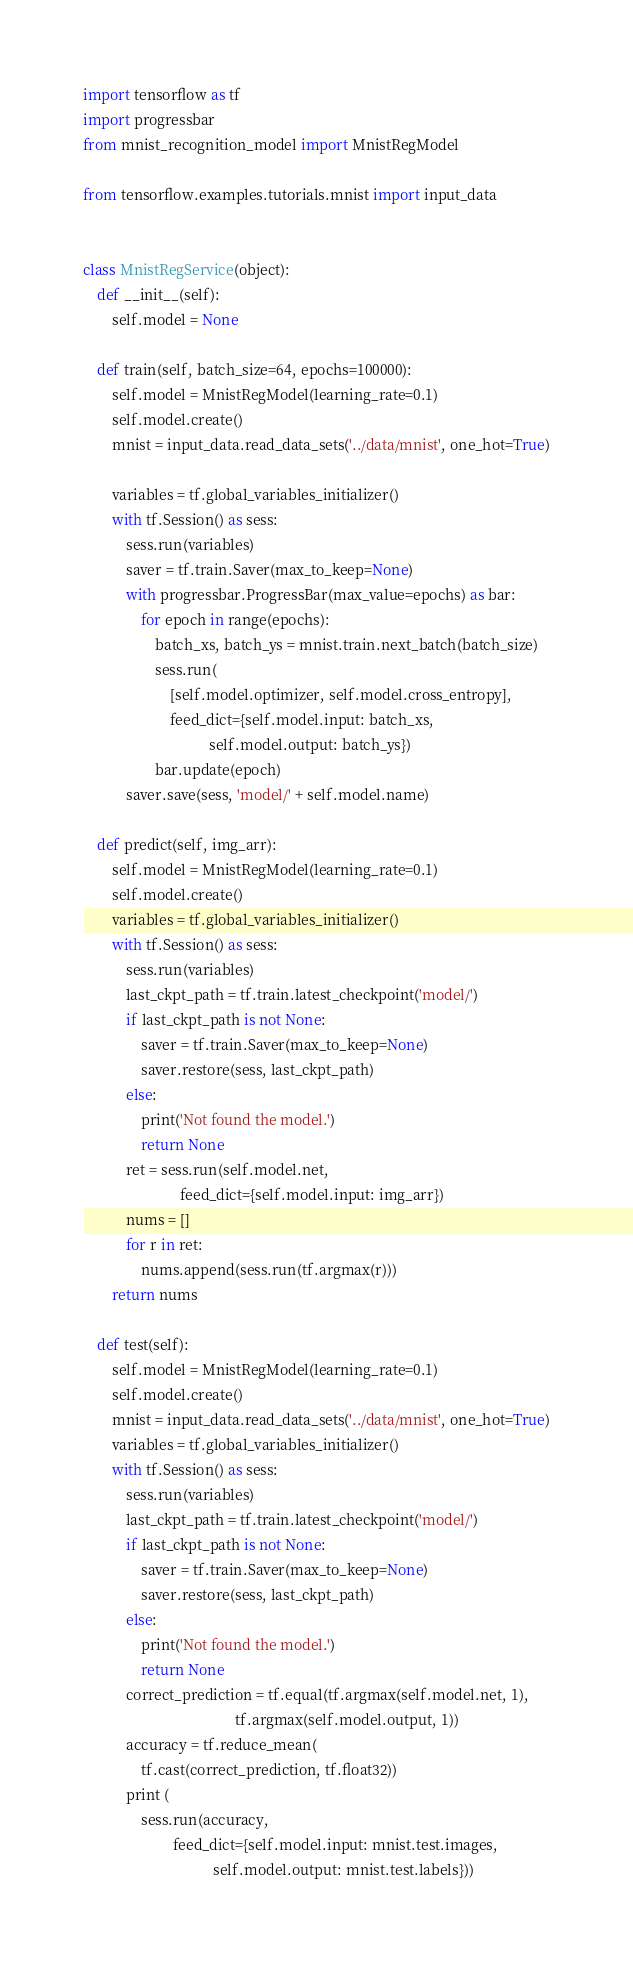Convert code to text. <code><loc_0><loc_0><loc_500><loc_500><_Python_>import tensorflow as tf
import progressbar
from mnist_recognition_model import MnistRegModel

from tensorflow.examples.tutorials.mnist import input_data


class MnistRegService(object):
    def __init__(self):
        self.model = None

    def train(self, batch_size=64, epochs=100000):
        self.model = MnistRegModel(learning_rate=0.1)
        self.model.create()
        mnist = input_data.read_data_sets('../data/mnist', one_hot=True)

        variables = tf.global_variables_initializer()
        with tf.Session() as sess:
            sess.run(variables)
            saver = tf.train.Saver(max_to_keep=None)
            with progressbar.ProgressBar(max_value=epochs) as bar:
                for epoch in range(epochs):
                    batch_xs, batch_ys = mnist.train.next_batch(batch_size)
                    sess.run(
                        [self.model.optimizer, self.model.cross_entropy],
                        feed_dict={self.model.input: batch_xs,
                                   self.model.output: batch_ys})
                    bar.update(epoch)
            saver.save(sess, 'model/' + self.model.name)

    def predict(self, img_arr):
        self.model = MnistRegModel(learning_rate=0.1)
        self.model.create()
        variables = tf.global_variables_initializer()
        with tf.Session() as sess:
            sess.run(variables)
            last_ckpt_path = tf.train.latest_checkpoint('model/')
            if last_ckpt_path is not None:
                saver = tf.train.Saver(max_to_keep=None)
                saver.restore(sess, last_ckpt_path)
            else:
                print('Not found the model.')
                return None
            ret = sess.run(self.model.net,
                           feed_dict={self.model.input: img_arr})
            nums = []
            for r in ret:
                nums.append(sess.run(tf.argmax(r)))
        return nums

    def test(self):
        self.model = MnistRegModel(learning_rate=0.1)
        self.model.create()
        mnist = input_data.read_data_sets('../data/mnist', one_hot=True)
        variables = tf.global_variables_initializer()
        with tf.Session() as sess:
            sess.run(variables)
            last_ckpt_path = tf.train.latest_checkpoint('model/')
            if last_ckpt_path is not None:
                saver = tf.train.Saver(max_to_keep=None)
                saver.restore(sess, last_ckpt_path)
            else:
                print('Not found the model.')
                return None
            correct_prediction = tf.equal(tf.argmax(self.model.net, 1),
                                          tf.argmax(self.model.output, 1))
            accuracy = tf.reduce_mean(
                tf.cast(correct_prediction, tf.float32))
            print (
                sess.run(accuracy,
                         feed_dict={self.model.input: mnist.test.images,
                                    self.model.output: mnist.test.labels}))
</code> 